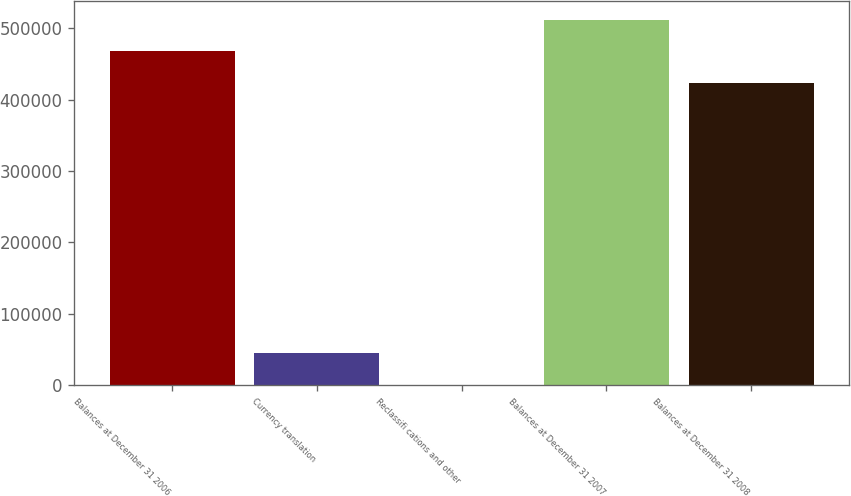Convert chart to OTSL. <chart><loc_0><loc_0><loc_500><loc_500><bar_chart><fcel>Balances at December 31 2006<fcel>Currency translation<fcel>Reclassifi cations and other<fcel>Balances at December 31 2007<fcel>Balances at December 31 2008<nl><fcel>467864<fcel>44320.5<fcel>118<fcel>512066<fcel>423661<nl></chart> 